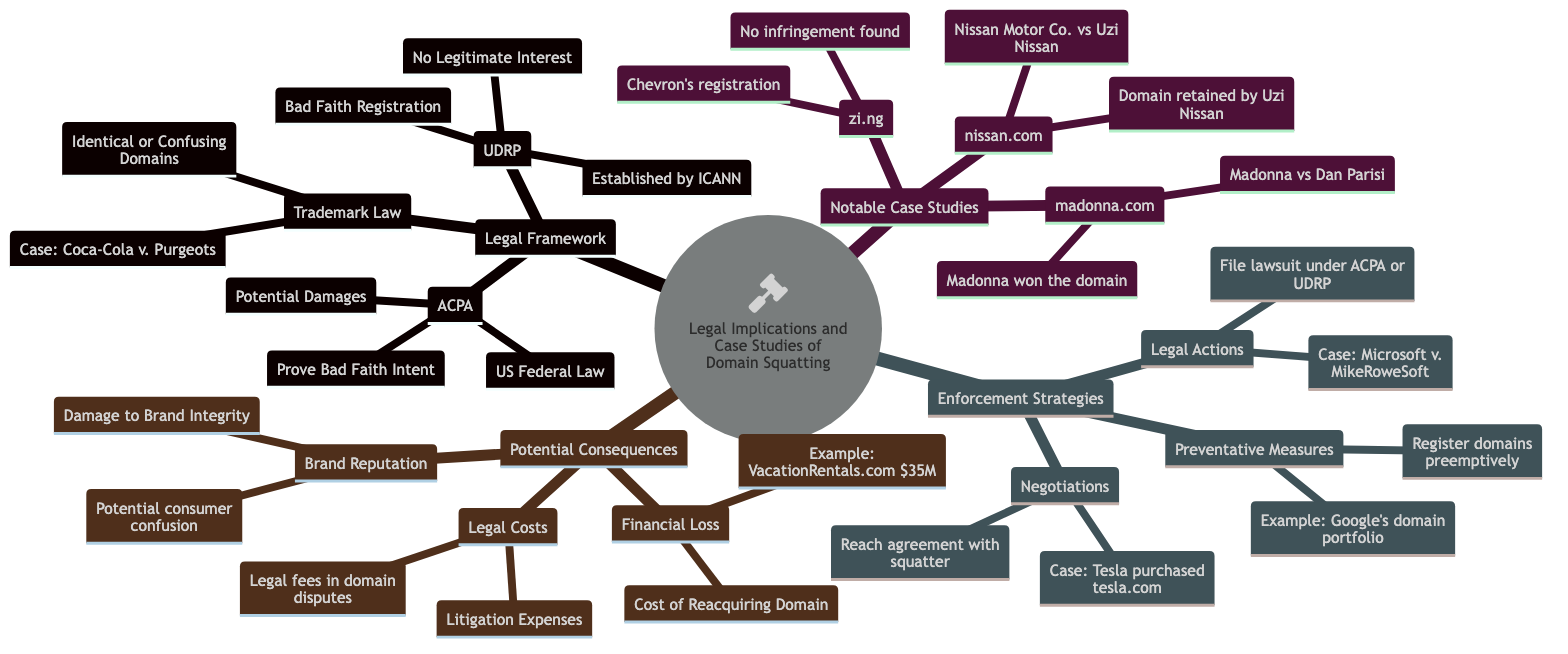What is UDRP? UDRP stands for Uniform Domain-Name Dispute-Resolution Policy, which is established by ICANN. It is located under the Legal Framework section of the mind map.
Answer: Uniform Domain-Name Dispute-Resolution Policy What are key provisions of ACPA? ACPA stands for Anticybersquatting Consumer Protection Act, and its key provisions include "Prove Bad Faith Intent" and "Potential Damages". This information can be found in the ACPA node under the Legal Framework.
Answer: Prove Bad Faith Intent, Potential Damages How has Madonna's case been resolved? Madonna's case against Dan Parisi was resolved in her favor, allowing her to win the domain. This information is found in the notable case studies section under madonna.com.
Answer: Madonna won the domain What was the outcome of the dispute over nissan.com? The dispute over nissan.com resulted in the domain being retained by Uzi Nissan, as indicated in the case study section for nissan.com.
Answer: Domain retained by Uzi Nissan What is a preventative measure against domain squatting? One preventative measure against domain squatting is registering domains preemptively, which is stated under the Preventative Measures section in Enforcement Strategies.
Answer: Registering domains preemptively How much did VacationRentals.com sell for? VacationRentals.com sold for $35 million, which is noted under the Financial Loss potential consequences in the mind map.
Answer: $35 million What type of law is ACPA? ACPA is identified as a U.S. Federal Law, which can be found in the ACPA section under the Legal Framework.
Answer: US Federal Law Which case involved a lawsuit under UDRP? The case of Microsoft v. MikeRoweSoft involved a lawsuit under UDRP, indicated in the Legal Actions section beneath Enforcement Strategies.
Answer: Microsoft v. MikeRoweSoft What organization established the UDRP? The UDRP was established by ICANN, which is present in the description of UDRP under Legal Framework.
Answer: ICANN 